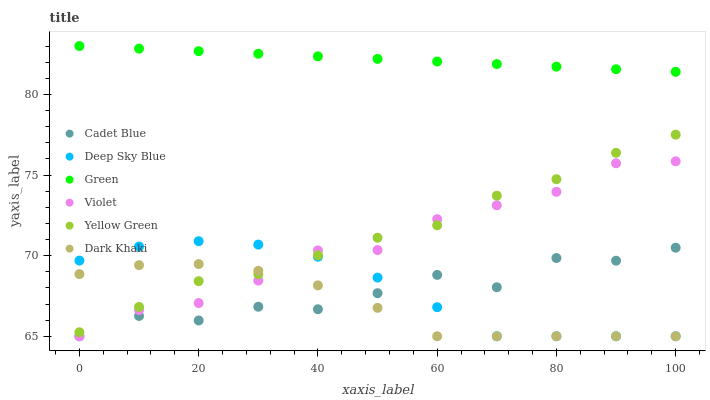Does Dark Khaki have the minimum area under the curve?
Answer yes or no. Yes. Does Green have the maximum area under the curve?
Answer yes or no. Yes. Does Yellow Green have the minimum area under the curve?
Answer yes or no. No. Does Yellow Green have the maximum area under the curve?
Answer yes or no. No. Is Green the smoothest?
Answer yes or no. Yes. Is Cadet Blue the roughest?
Answer yes or no. Yes. Is Yellow Green the smoothest?
Answer yes or no. No. Is Yellow Green the roughest?
Answer yes or no. No. Does Cadet Blue have the lowest value?
Answer yes or no. Yes. Does Yellow Green have the lowest value?
Answer yes or no. No. Does Green have the highest value?
Answer yes or no. Yes. Does Yellow Green have the highest value?
Answer yes or no. No. Is Cadet Blue less than Green?
Answer yes or no. Yes. Is Green greater than Deep Sky Blue?
Answer yes or no. Yes. Does Yellow Green intersect Dark Khaki?
Answer yes or no. Yes. Is Yellow Green less than Dark Khaki?
Answer yes or no. No. Is Yellow Green greater than Dark Khaki?
Answer yes or no. No. Does Cadet Blue intersect Green?
Answer yes or no. No. 